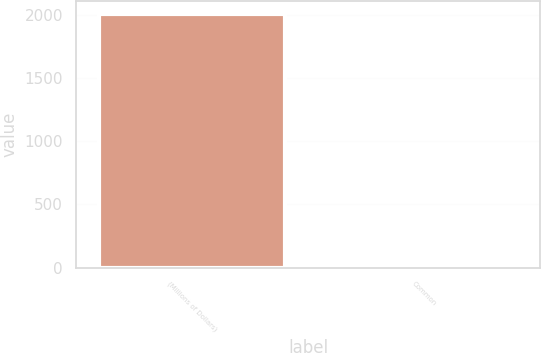Convert chart to OTSL. <chart><loc_0><loc_0><loc_500><loc_500><bar_chart><fcel>(Millions of Dollars)<fcel>Common<nl><fcel>2012<fcel>3<nl></chart> 